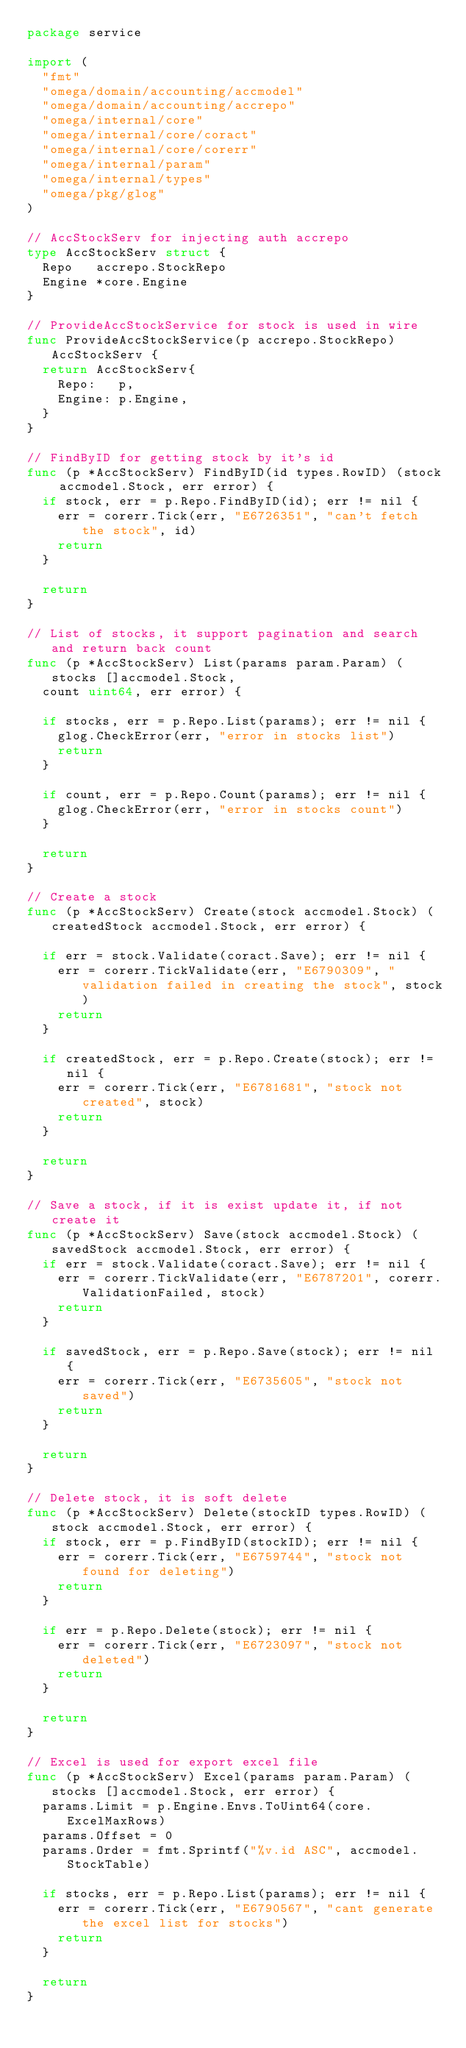<code> <loc_0><loc_0><loc_500><loc_500><_Go_>package service

import (
	"fmt"
	"omega/domain/accounting/accmodel"
	"omega/domain/accounting/accrepo"
	"omega/internal/core"
	"omega/internal/core/coract"
	"omega/internal/core/corerr"
	"omega/internal/param"
	"omega/internal/types"
	"omega/pkg/glog"
)

// AccStockServ for injecting auth accrepo
type AccStockServ struct {
	Repo   accrepo.StockRepo
	Engine *core.Engine
}

// ProvideAccStockService for stock is used in wire
func ProvideAccStockService(p accrepo.StockRepo) AccStockServ {
	return AccStockServ{
		Repo:   p,
		Engine: p.Engine,
	}
}

// FindByID for getting stock by it's id
func (p *AccStockServ) FindByID(id types.RowID) (stock accmodel.Stock, err error) {
	if stock, err = p.Repo.FindByID(id); err != nil {
		err = corerr.Tick(err, "E6726351", "can't fetch the stock", id)
		return
	}

	return
}

// List of stocks, it support pagination and search and return back count
func (p *AccStockServ) List(params param.Param) (stocks []accmodel.Stock,
	count uint64, err error) {

	if stocks, err = p.Repo.List(params); err != nil {
		glog.CheckError(err, "error in stocks list")
		return
	}

	if count, err = p.Repo.Count(params); err != nil {
		glog.CheckError(err, "error in stocks count")
	}

	return
}

// Create a stock
func (p *AccStockServ) Create(stock accmodel.Stock) (createdStock accmodel.Stock, err error) {

	if err = stock.Validate(coract.Save); err != nil {
		err = corerr.TickValidate(err, "E6790309", "validation failed in creating the stock", stock)
		return
	}

	if createdStock, err = p.Repo.Create(stock); err != nil {
		err = corerr.Tick(err, "E6781681", "stock not created", stock)
		return
	}

	return
}

// Save a stock, if it is exist update it, if not create it
func (p *AccStockServ) Save(stock accmodel.Stock) (savedStock accmodel.Stock, err error) {
	if err = stock.Validate(coract.Save); err != nil {
		err = corerr.TickValidate(err, "E6787201", corerr.ValidationFailed, stock)
		return
	}

	if savedStock, err = p.Repo.Save(stock); err != nil {
		err = corerr.Tick(err, "E6735605", "stock not saved")
		return
	}

	return
}

// Delete stock, it is soft delete
func (p *AccStockServ) Delete(stockID types.RowID) (stock accmodel.Stock, err error) {
	if stock, err = p.FindByID(stockID); err != nil {
		err = corerr.Tick(err, "E6759744", "stock not found for deleting")
		return
	}

	if err = p.Repo.Delete(stock); err != nil {
		err = corerr.Tick(err, "E6723097", "stock not deleted")
		return
	}

	return
}

// Excel is used for export excel file
func (p *AccStockServ) Excel(params param.Param) (stocks []accmodel.Stock, err error) {
	params.Limit = p.Engine.Envs.ToUint64(core.ExcelMaxRows)
	params.Offset = 0
	params.Order = fmt.Sprintf("%v.id ASC", accmodel.StockTable)

	if stocks, err = p.Repo.List(params); err != nil {
		err = corerr.Tick(err, "E6790567", "cant generate the excel list for stocks")
		return
	}

	return
}
</code> 